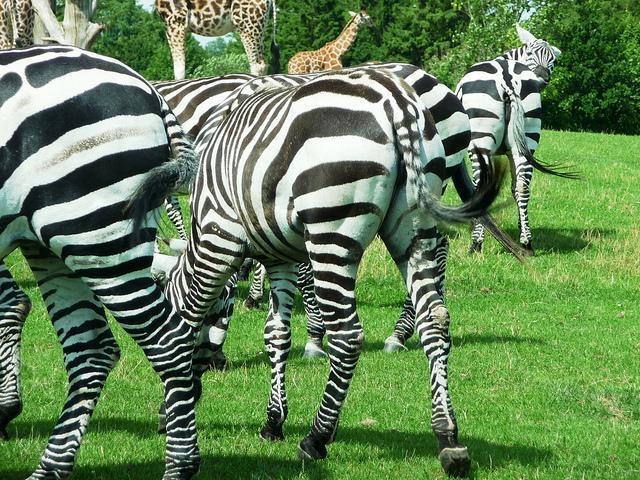How many different types of animals are there?
Give a very brief answer. 2. How many animals are in this picture?
Give a very brief answer. 7. How many giraffes are there?
Give a very brief answer. 2. How many zebras are there?
Give a very brief answer. 5. 